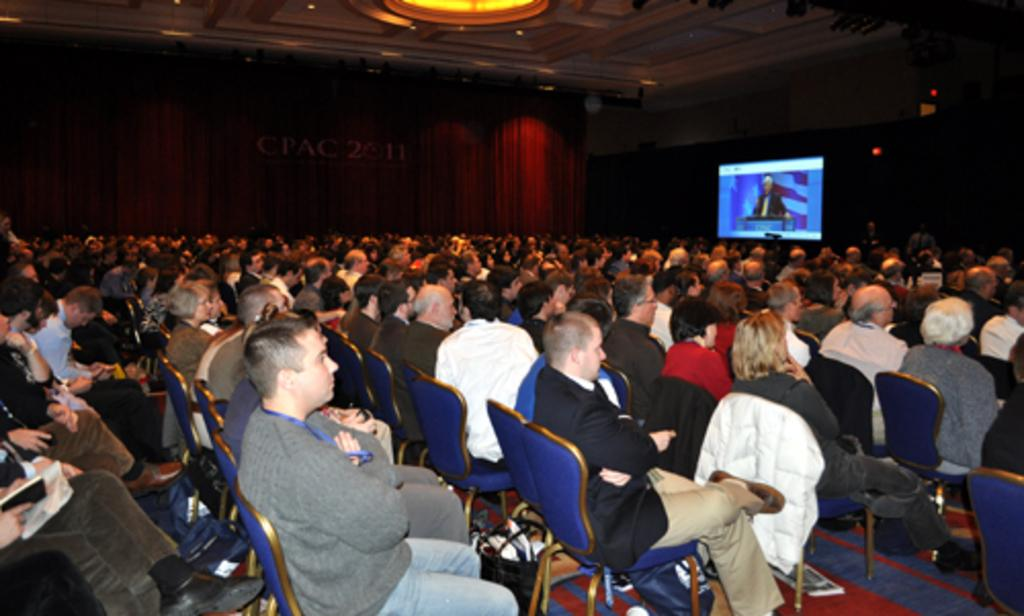How many people are in the image? There is a group of persons in the image. What are the persons doing in the image? The persons are sitting on chairs. What is the flooring material beneath the chairs? The chairs are on a carpet. What can be seen in the background of the image? There is a screen and a curtain in the background of the image. What is the alarm condition in the image? There is no mention of an alarm or any condition in the image. 